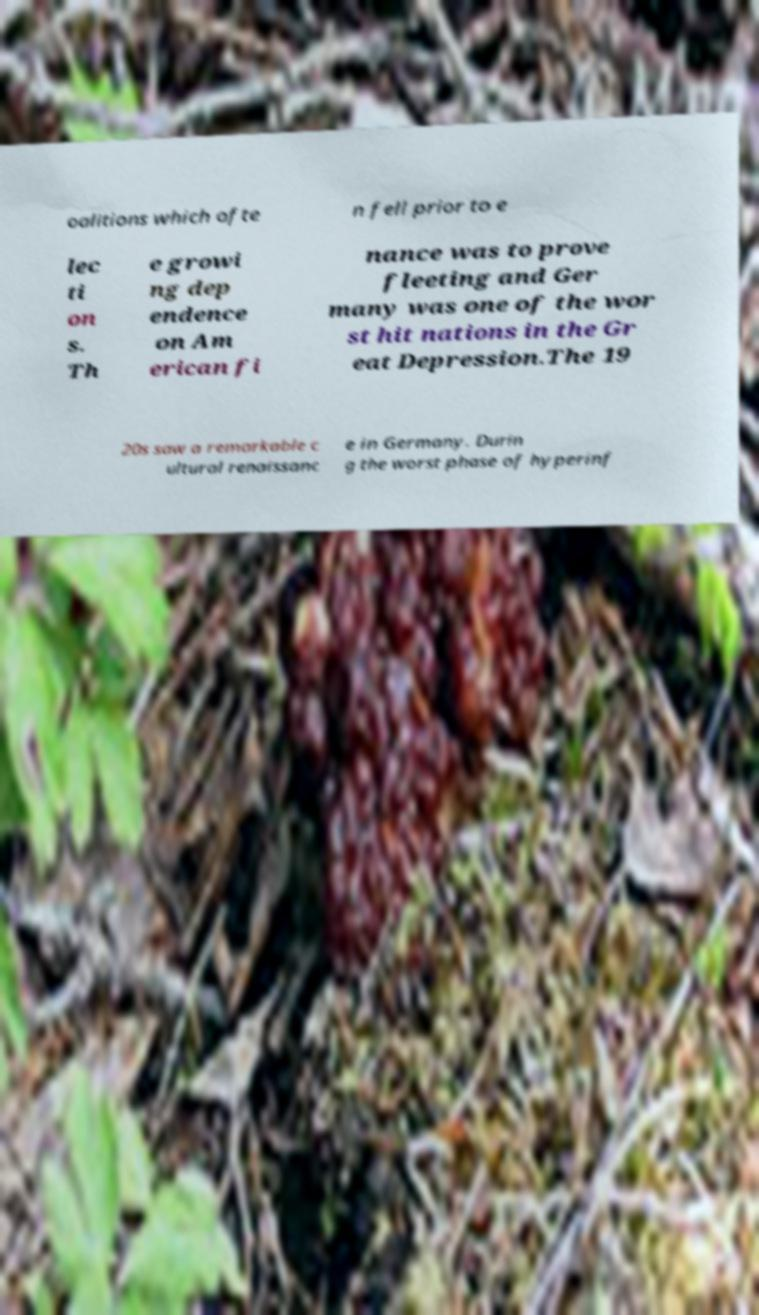For documentation purposes, I need the text within this image transcribed. Could you provide that? oalitions which ofte n fell prior to e lec ti on s. Th e growi ng dep endence on Am erican fi nance was to prove fleeting and Ger many was one of the wor st hit nations in the Gr eat Depression.The 19 20s saw a remarkable c ultural renaissanc e in Germany. Durin g the worst phase of hyperinf 